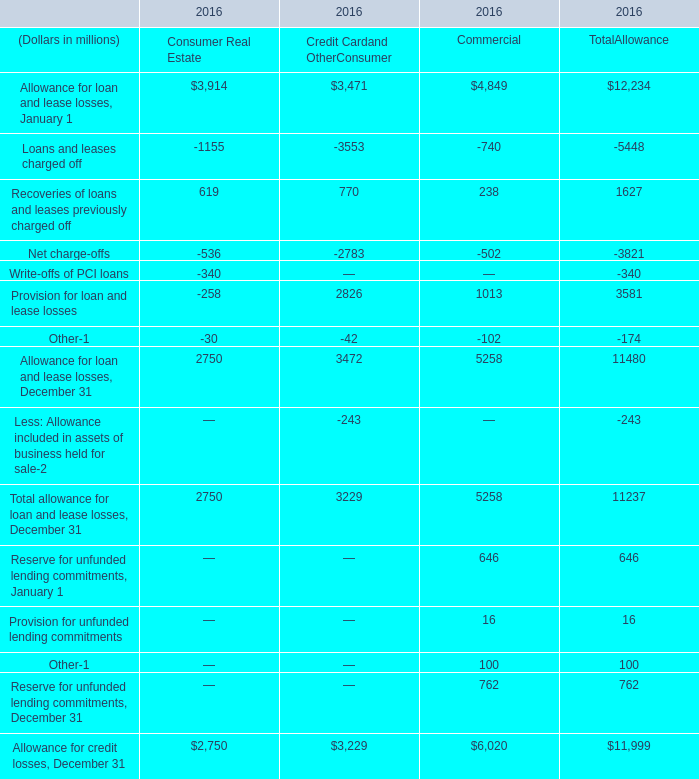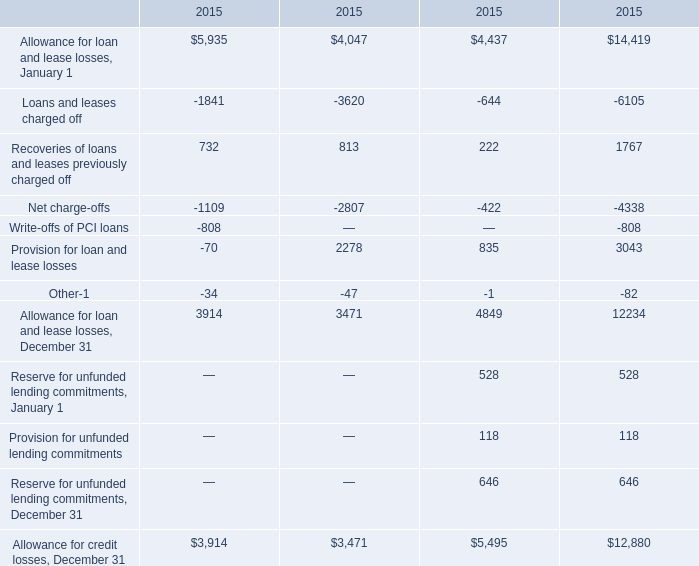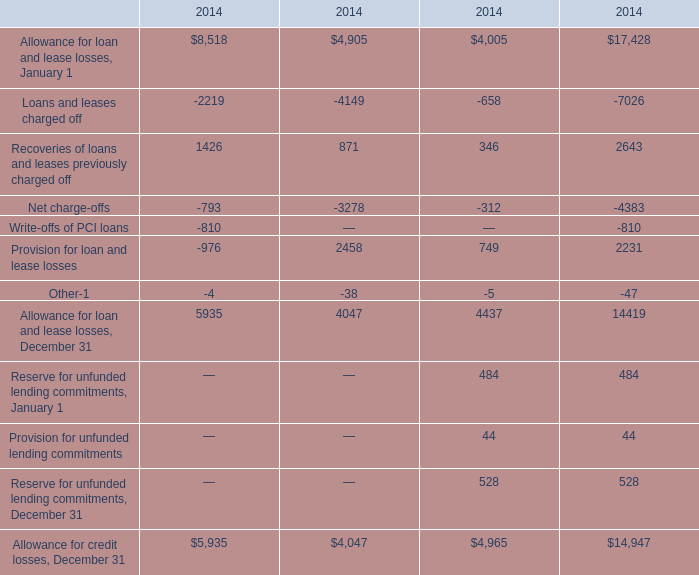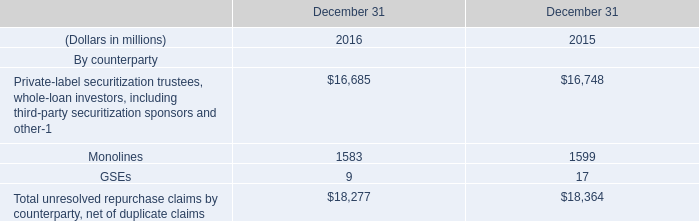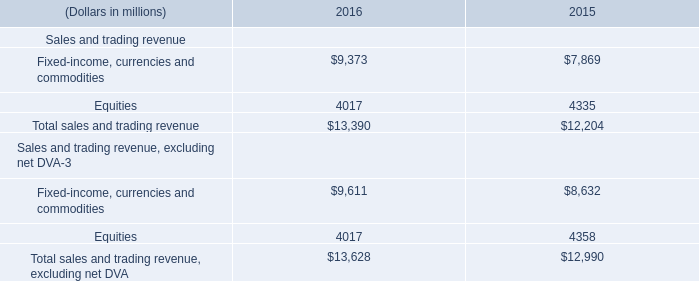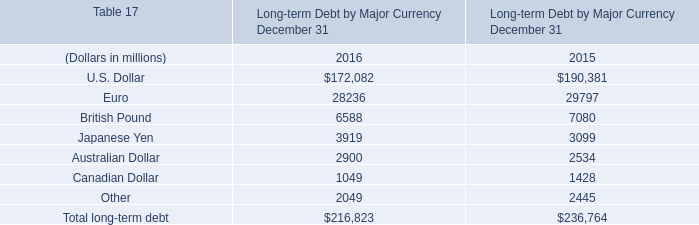What is the average amount of Loans and leases charged off of 2016 Credit Cardand OtherConsumer, and Allowance for loan and lease losses, December 31 of 2015.3 ? 
Computations: ((3553.0 + 12234.0) / 2)
Answer: 7893.5. 